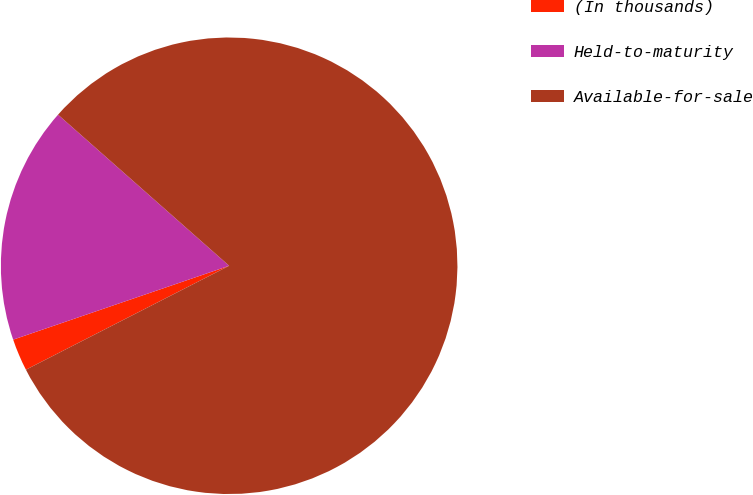Convert chart. <chart><loc_0><loc_0><loc_500><loc_500><pie_chart><fcel>(In thousands)<fcel>Held-to-maturity<fcel>Available-for-sale<nl><fcel>2.28%<fcel>16.76%<fcel>80.96%<nl></chart> 